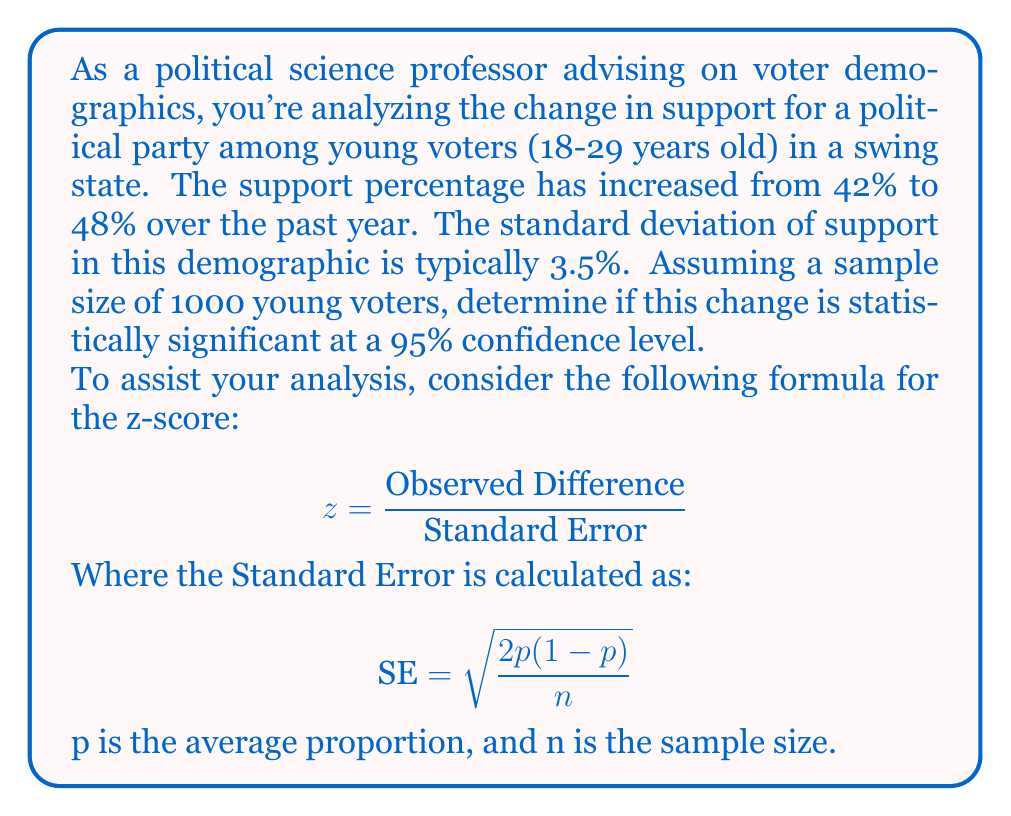Provide a solution to this math problem. To determine if the change is statistically significant, we'll follow these steps:

1. Calculate the observed difference:
   $48\% - 42\% = 6\%$ or $0.06$

2. Calculate the average proportion (p):
   $p = \frac{42\% + 48\%}{2} = 45\%$ or $0.45$

3. Calculate the Standard Error (SE):
   $$ \text{SE} = \sqrt{\frac{2(0.45)(1-0.45)}{1000}} = \sqrt{\frac{0.495}{1000}} = 0.0222 $$

4. Calculate the z-score:
   $$ z = \frac{0.06}{0.0222} = 2.70 $$

5. Determine the critical z-value for a 95% confidence level:
   The critical z-value for a two-tailed test at 95% confidence is 1.96.

6. Compare the calculated z-score to the critical value:
   Our z-score (2.70) is greater than the critical value (1.96).

Therefore, the change is statistically significant at the 95% confidence level. This means we can be 95% confident that the observed change in support is not due to random chance.

Note: We didn't directly use the given standard deviation (3.5%) because we're comparing two proportions rather than a single proportion to a known population parameter. The formula we used is specific for comparing two proportions from the same population at different times.
Answer: Statistically significant (z = 2.70 > 1.96) 